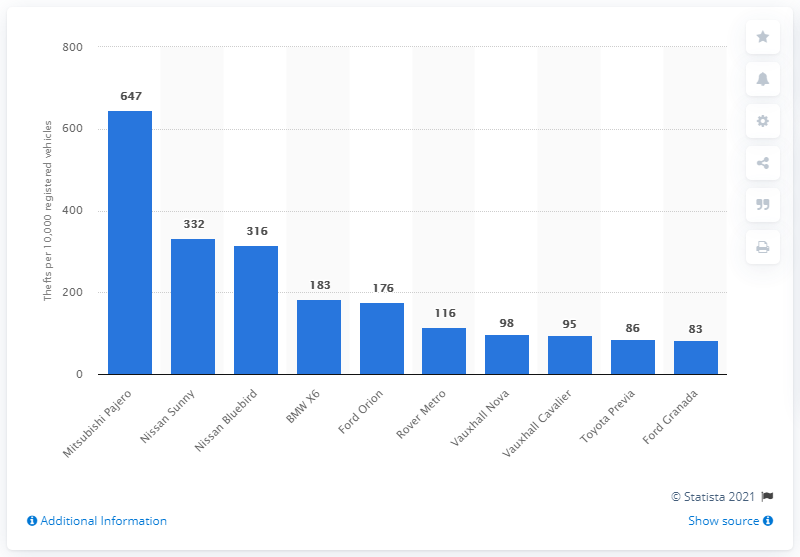List a handful of essential elements in this visual. According to data from 2011 and 2012, the Mitsubishi Pajero was the car model with the highest theft rate in Great Britain. 